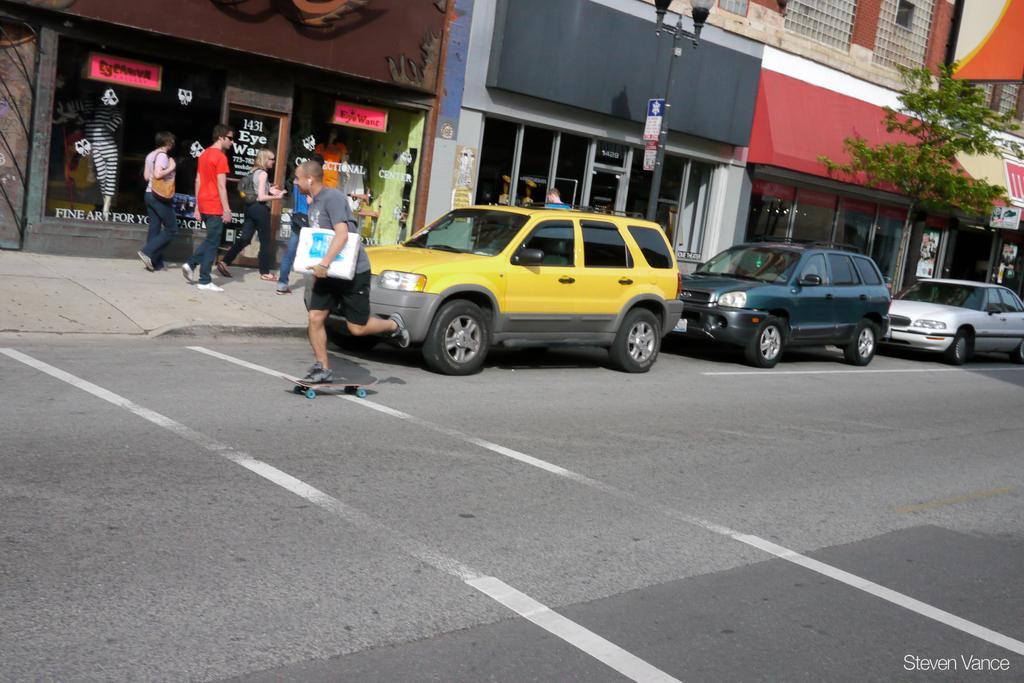Can you describe this image briefly? In this image we can see cars on the road and there are people. In the background there are buildings and boards. There is a tree. 